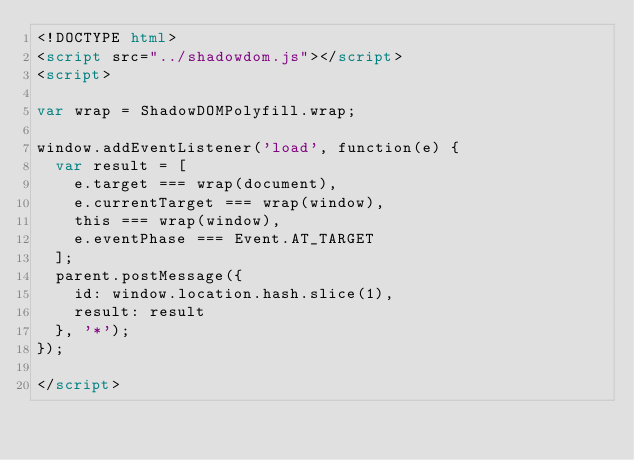Convert code to text. <code><loc_0><loc_0><loc_500><loc_500><_HTML_><!DOCTYPE html>
<script src="../shadowdom.js"></script>
<script>

var wrap = ShadowDOMPolyfill.wrap;

window.addEventListener('load', function(e) {
  var result = [
    e.target === wrap(document),
    e.currentTarget === wrap(window),
    this === wrap(window),
    e.eventPhase === Event.AT_TARGET
  ];
  parent.postMessage({
    id: window.location.hash.slice(1),
    result: result
  }, '*');
});

</script>
</code> 